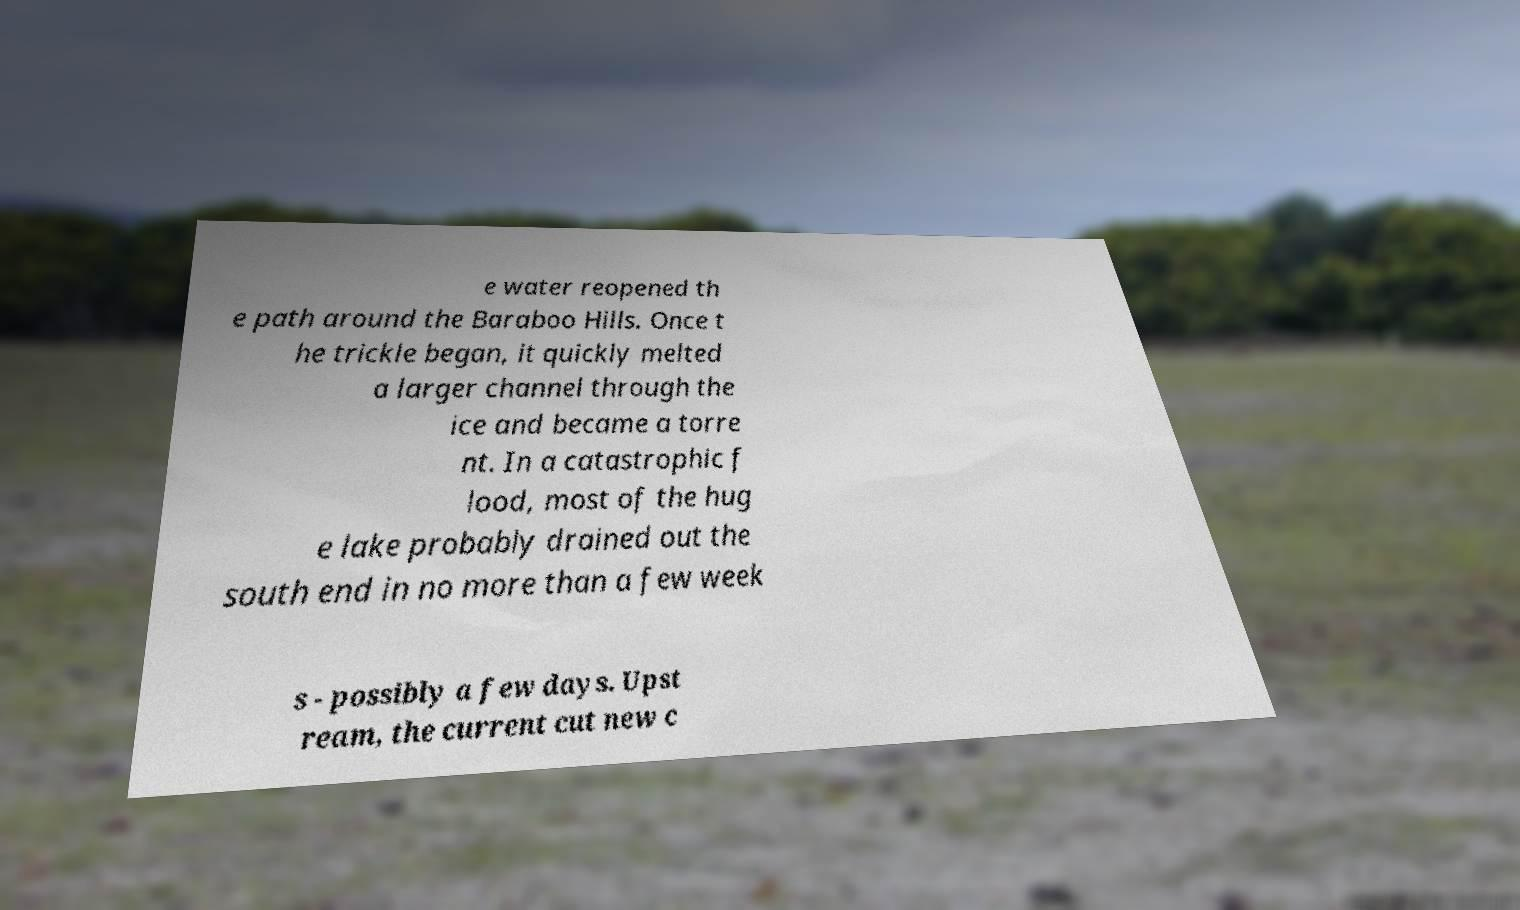Can you accurately transcribe the text from the provided image for me? e water reopened th e path around the Baraboo Hills. Once t he trickle began, it quickly melted a larger channel through the ice and became a torre nt. In a catastrophic f lood, most of the hug e lake probably drained out the south end in no more than a few week s - possibly a few days. Upst ream, the current cut new c 